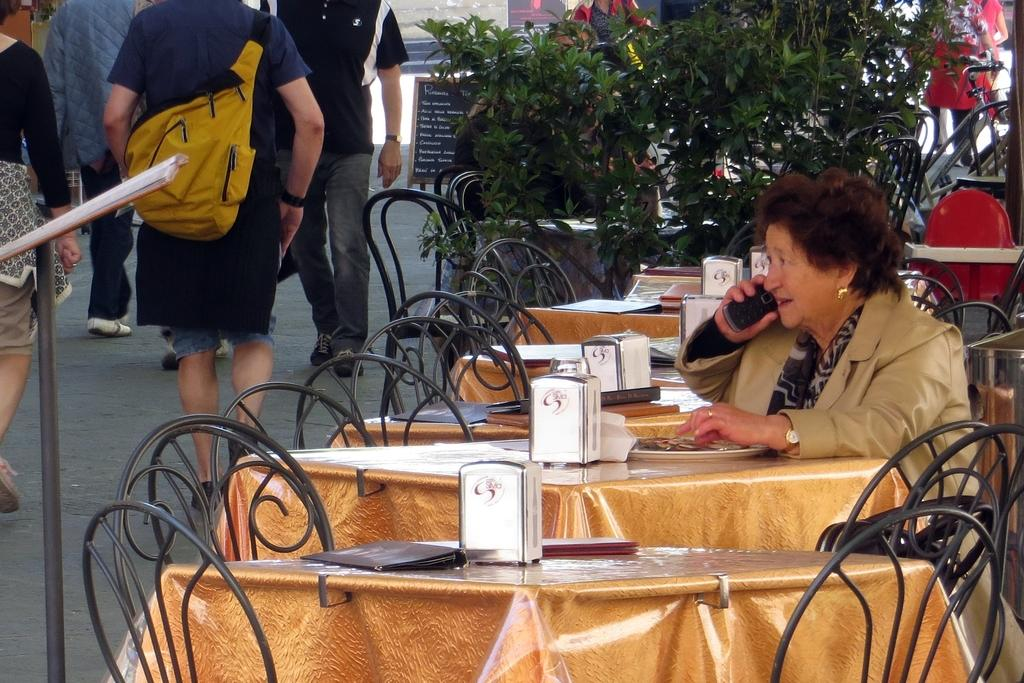What is the woman in the image doing? The woman is sitting on a chair in front of a table and is on a call. What can be seen in the background of the image? There are plants visible in the image. What is happening outside the window in the image? There are people walking on the road. What object can be seen in the image besides the woman and the plants? There is a board in the image. What type of fang can be seen in the image? There are no fangs present in the image. What part of the brain is visible in the image? There is no brain visible in the image. 